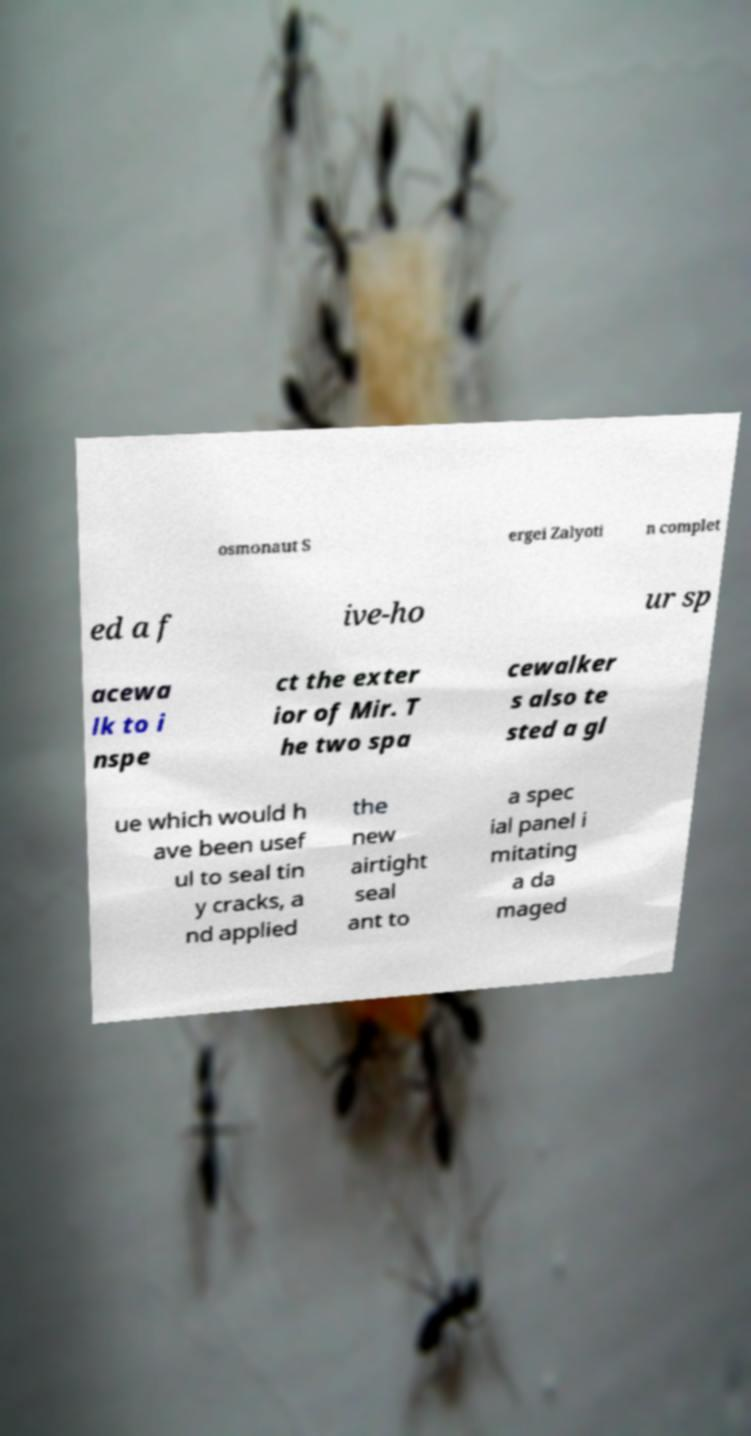Could you assist in decoding the text presented in this image and type it out clearly? osmonaut S ergei Zalyoti n complet ed a f ive-ho ur sp acewa lk to i nspe ct the exter ior of Mir. T he two spa cewalker s also te sted a gl ue which would h ave been usef ul to seal tin y cracks, a nd applied the new airtight seal ant to a spec ial panel i mitating a da maged 